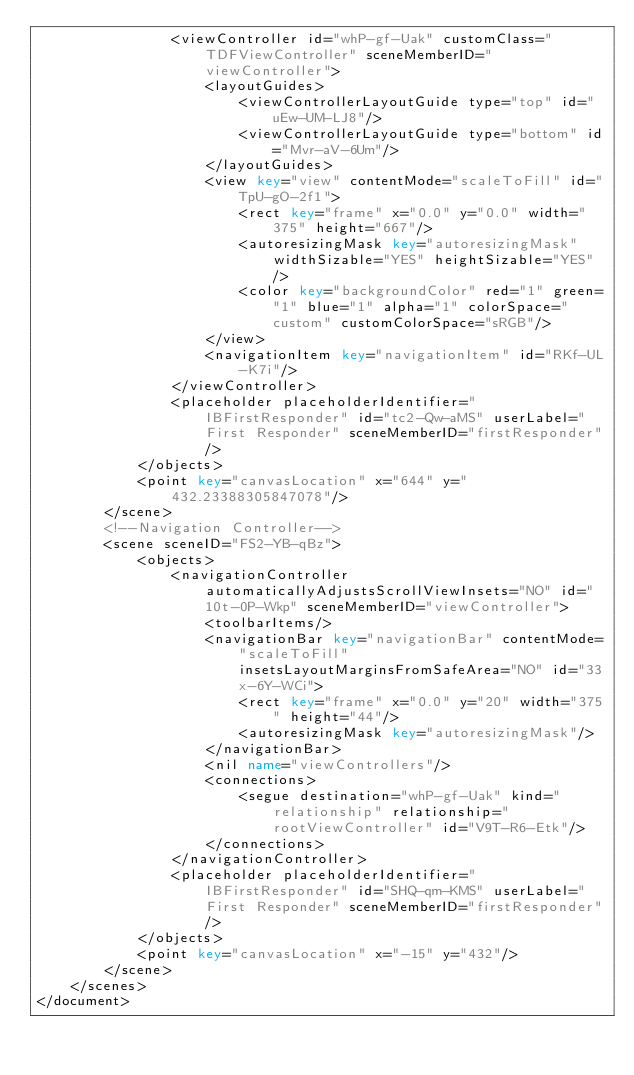<code> <loc_0><loc_0><loc_500><loc_500><_XML_>                <viewController id="whP-gf-Uak" customClass="TDFViewController" sceneMemberID="viewController">
                    <layoutGuides>
                        <viewControllerLayoutGuide type="top" id="uEw-UM-LJ8"/>
                        <viewControllerLayoutGuide type="bottom" id="Mvr-aV-6Um"/>
                    </layoutGuides>
                    <view key="view" contentMode="scaleToFill" id="TpU-gO-2f1">
                        <rect key="frame" x="0.0" y="0.0" width="375" height="667"/>
                        <autoresizingMask key="autoresizingMask" widthSizable="YES" heightSizable="YES"/>
                        <color key="backgroundColor" red="1" green="1" blue="1" alpha="1" colorSpace="custom" customColorSpace="sRGB"/>
                    </view>
                    <navigationItem key="navigationItem" id="RKf-UL-K7i"/>
                </viewController>
                <placeholder placeholderIdentifier="IBFirstResponder" id="tc2-Qw-aMS" userLabel="First Responder" sceneMemberID="firstResponder"/>
            </objects>
            <point key="canvasLocation" x="644" y="432.23388305847078"/>
        </scene>
        <!--Navigation Controller-->
        <scene sceneID="FS2-YB-qBz">
            <objects>
                <navigationController automaticallyAdjustsScrollViewInsets="NO" id="10t-0P-Wkp" sceneMemberID="viewController">
                    <toolbarItems/>
                    <navigationBar key="navigationBar" contentMode="scaleToFill" insetsLayoutMarginsFromSafeArea="NO" id="33x-6Y-WCi">
                        <rect key="frame" x="0.0" y="20" width="375" height="44"/>
                        <autoresizingMask key="autoresizingMask"/>
                    </navigationBar>
                    <nil name="viewControllers"/>
                    <connections>
                        <segue destination="whP-gf-Uak" kind="relationship" relationship="rootViewController" id="V9T-R6-Etk"/>
                    </connections>
                </navigationController>
                <placeholder placeholderIdentifier="IBFirstResponder" id="SHQ-qm-KMS" userLabel="First Responder" sceneMemberID="firstResponder"/>
            </objects>
            <point key="canvasLocation" x="-15" y="432"/>
        </scene>
    </scenes>
</document>
</code> 